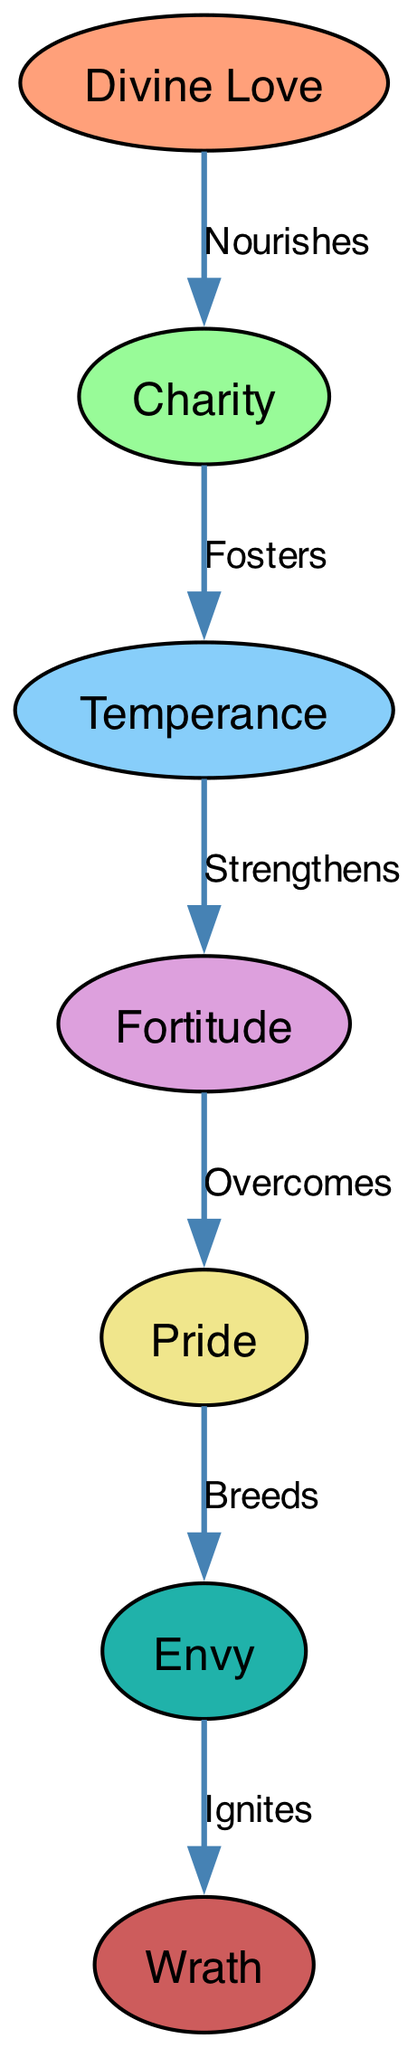What is the highest virtue represented in the diagram? The highest virtue represented in the diagram is found at the top of the food chain, with "Divine Love" being the first node and the source of nourishment for the others.
Answer: Divine Love Which vice is ignited by envy? To find the vice ignited by envy, we look towards the end of the flow from "Envy" to "Wrath" as indicated by the “Ignites” relationship.
Answer: Wrath How many nodes are there in total? By counting the nodes listed in the diagram, we find there are seven distinct nodes representing the virtues and vices within the food chain.
Answer: 7 What is the relationship between charity and temperance? Examining the edge that connects "Charity" to "Temperance," we see the label "Fosters," indicating the nurturing influence of charity on temperance.
Answer: Fosters Which vice breeds pride? By inspecting the flow in the diagram and the edge from "Pride," we recognize that it is preceded by "Fortitude" which leads us to understand that pride is bred as a consequence of the previous virtue.
Answer: Pride What color represents temperance in the diagram? Each node in the diagram is colored according to a defined scheme; referring to the color associated with "Temperance," we confirm it is represented by Light Sky Blue.
Answer: Light Sky Blue How does fortitude relate to pride? To address this, we look at the connecting edge from "Fortitude" to "Pride" labeled "Overcomes," showing that fortitude is important in conquering or overcoming pride.
Answer: Overcomes What is the sequence of virtues leading to fortitude? To determine the sequence that leads to "Fortitude," we trace back from the nodes, noticing that "Temperance" strengthens fortitude, which itself is fostered by charity and nourished by divine love.
Answer: Divine Love → Charity → Temperance → Fortitude Which virtue is immediately nourished by divine love? Directly observing the edge that extends from "Divine Love," it's clear that "Charity" is the first virtue to be nourished by this divine source.
Answer: Charity 